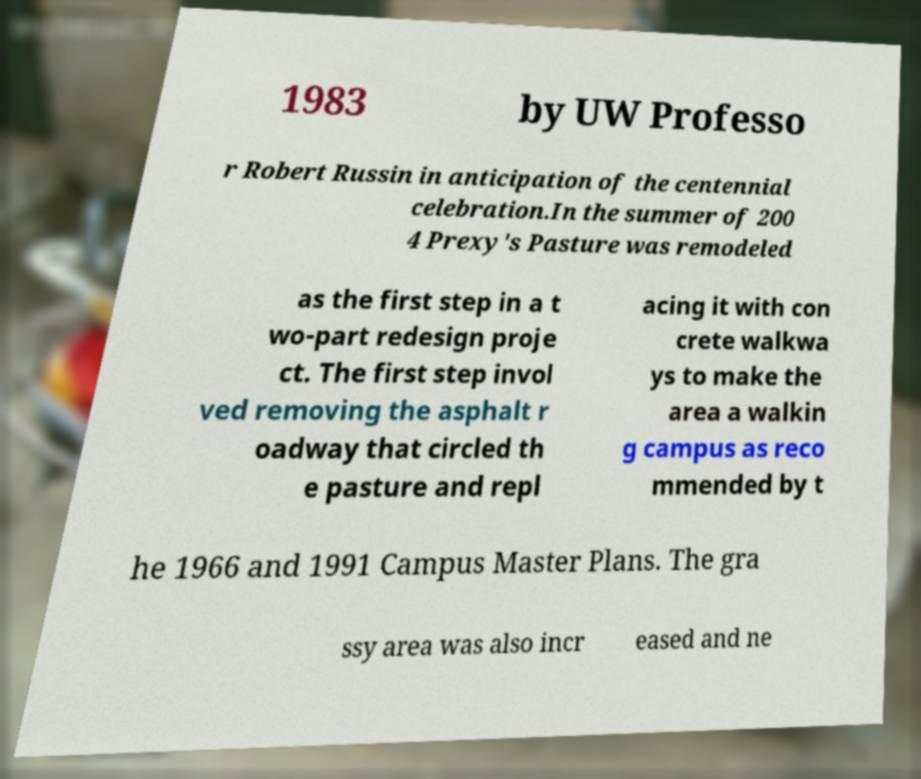Could you extract and type out the text from this image? 1983 by UW Professo r Robert Russin in anticipation of the centennial celebration.In the summer of 200 4 Prexy's Pasture was remodeled as the first step in a t wo-part redesign proje ct. The first step invol ved removing the asphalt r oadway that circled th e pasture and repl acing it with con crete walkwa ys to make the area a walkin g campus as reco mmended by t he 1966 and 1991 Campus Master Plans. The gra ssy area was also incr eased and ne 